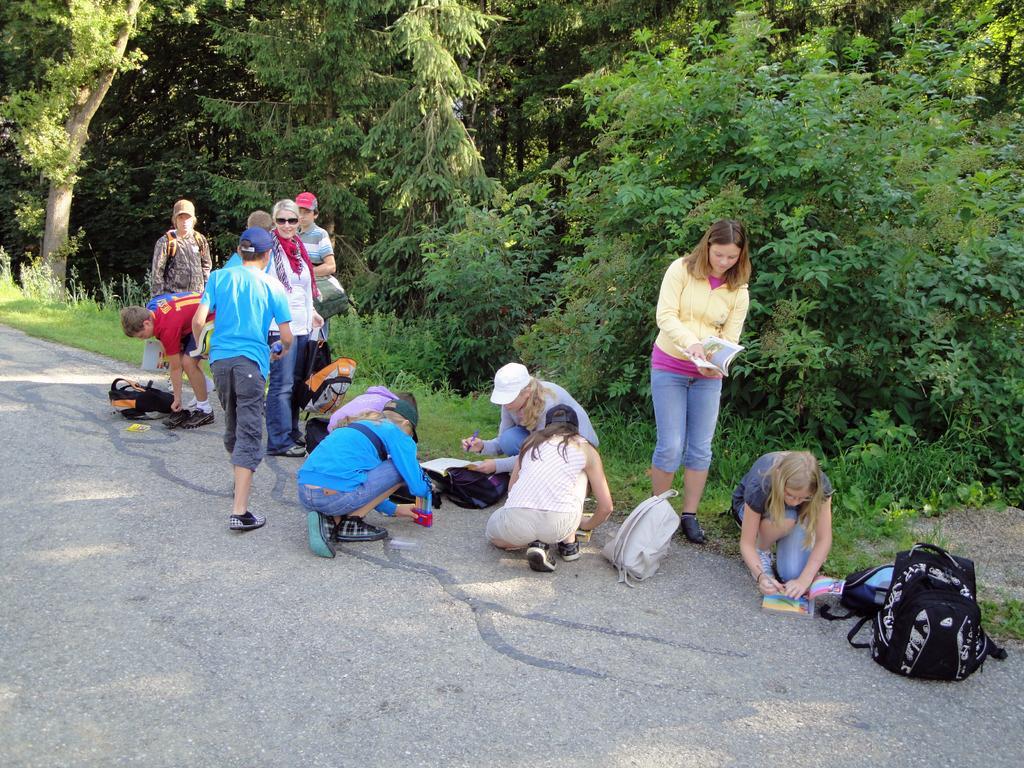Please provide a concise description of this image. In this image, few peoples are there. Few are writing on the books. Few are standing. They are holding bags. We can see so many backpacks and road. And background, we can see so many trees and plants. 